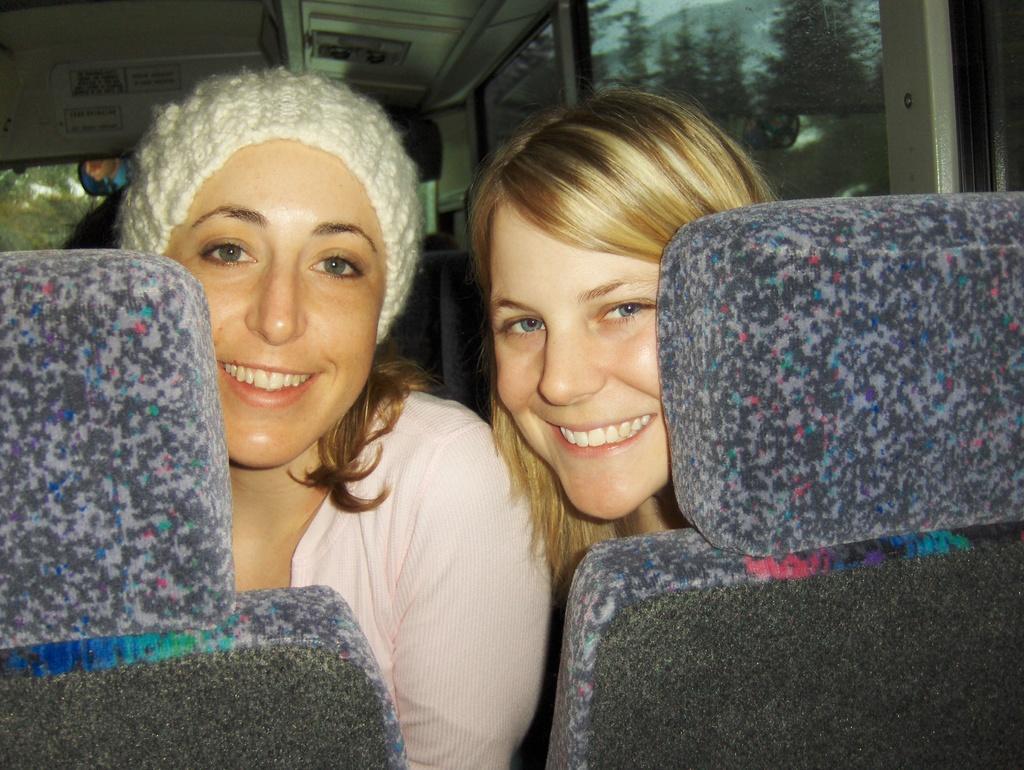Could you give a brief overview of what you see in this image? This image is clicked inside a vehicle. There are two women sitting on the seats. They are smiling. Beside them there are glass windows to the vehicle. Outside the windows there are trees. 